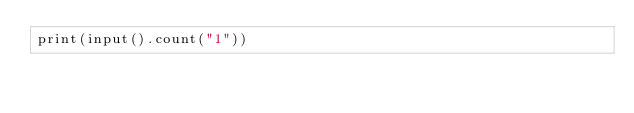<code> <loc_0><loc_0><loc_500><loc_500><_C++_>print(input().count("1"))</code> 